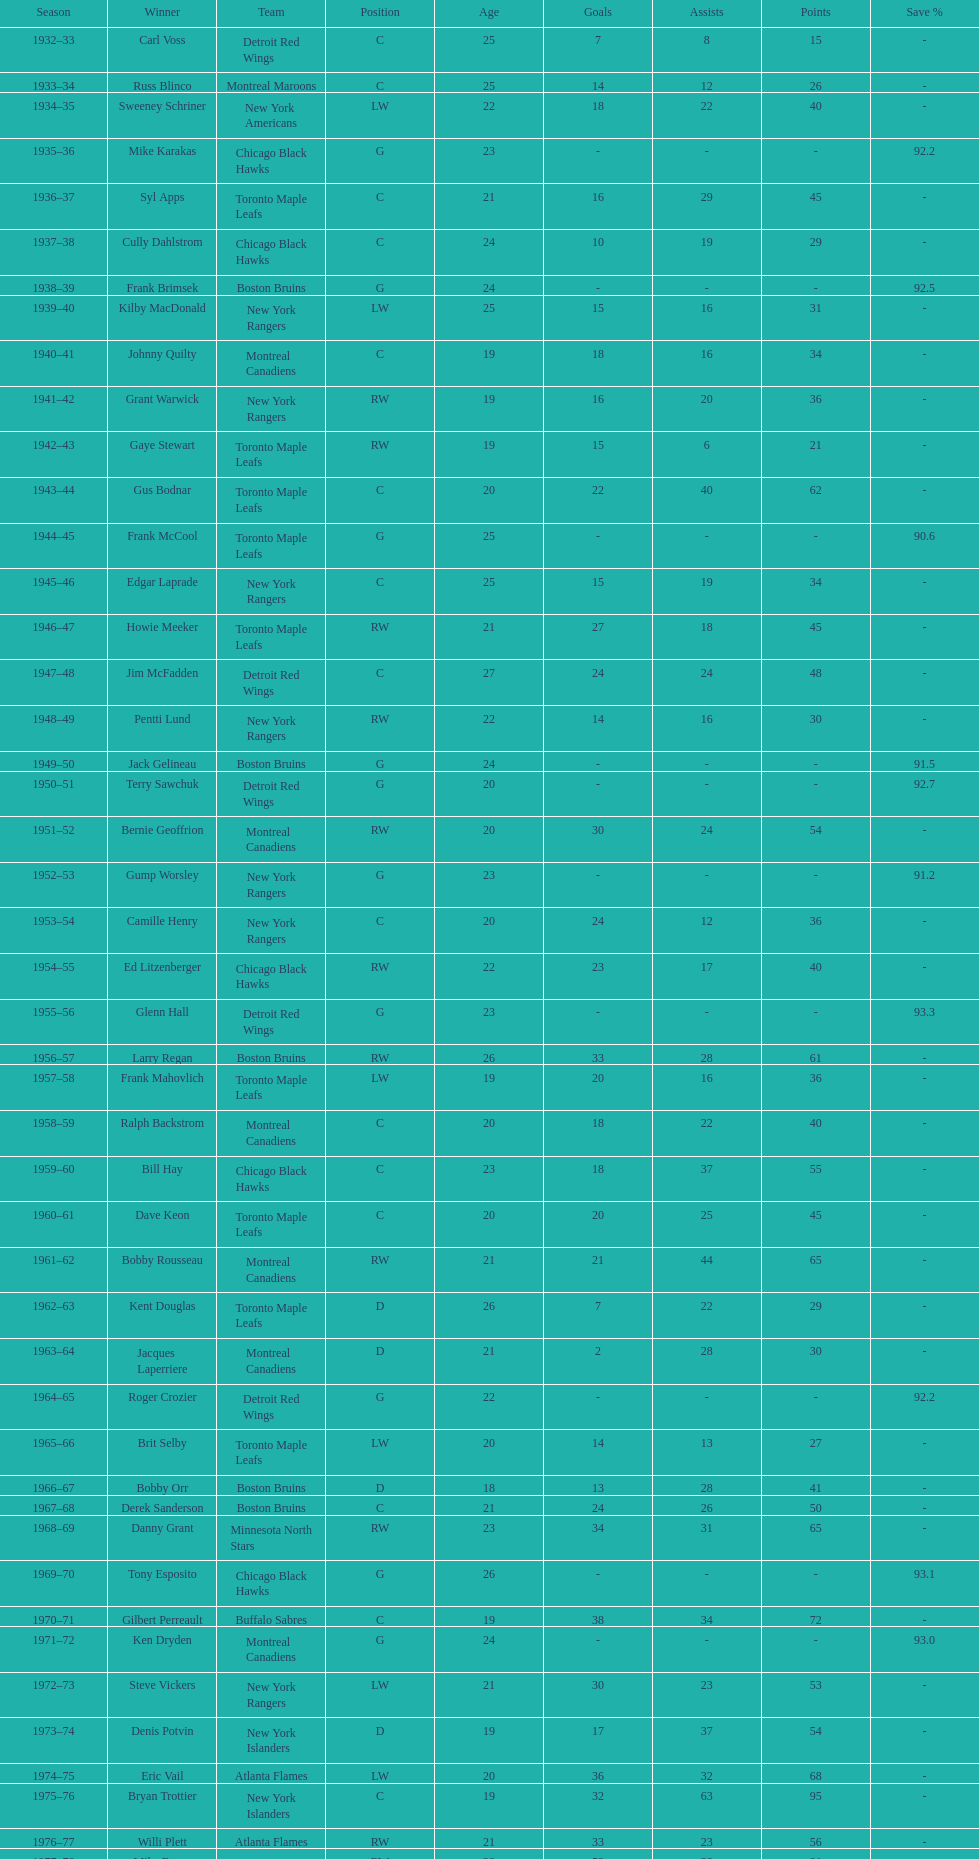Which team has the highest number of consecutive calder memorial trophy winners? Toronto Maple Leafs. 